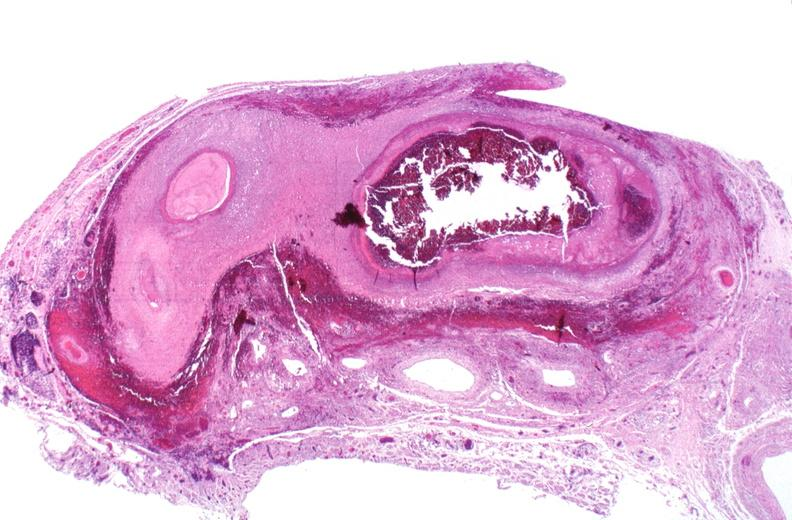where is this from?
Answer the question using a single word or phrase. Vasculature 